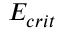<formula> <loc_0><loc_0><loc_500><loc_500>E _ { c r i t }</formula> 